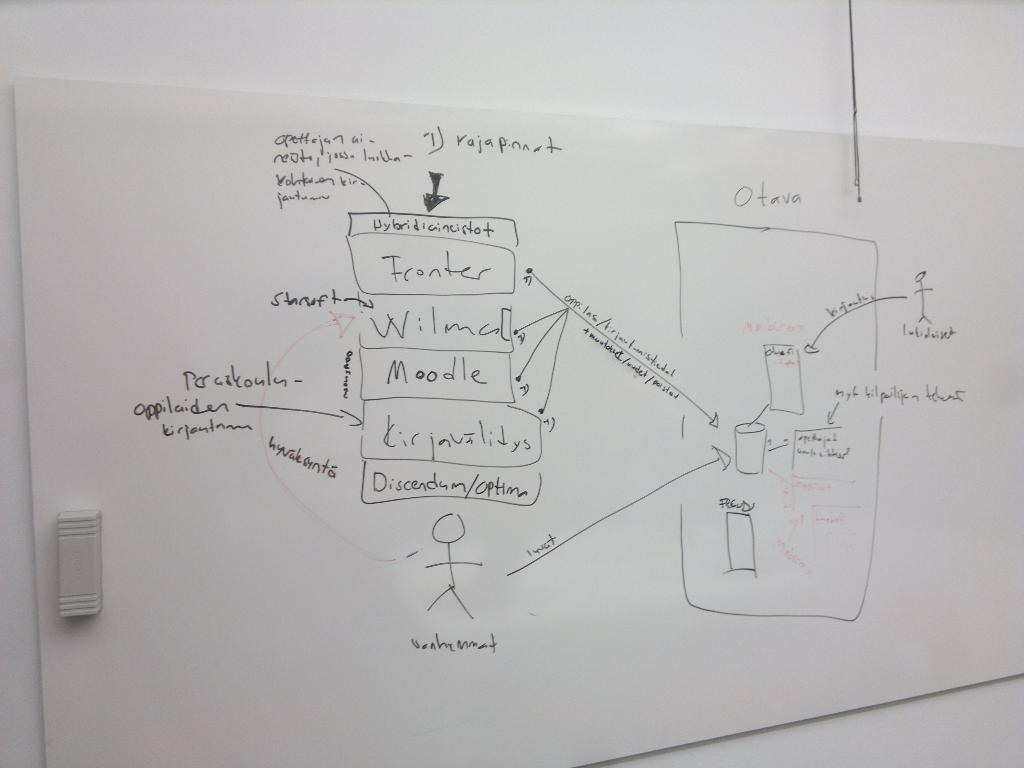Provide a one-sentence caption for the provided image. A diagram on a white board shows various processes, such as Moodle, and Franker. 